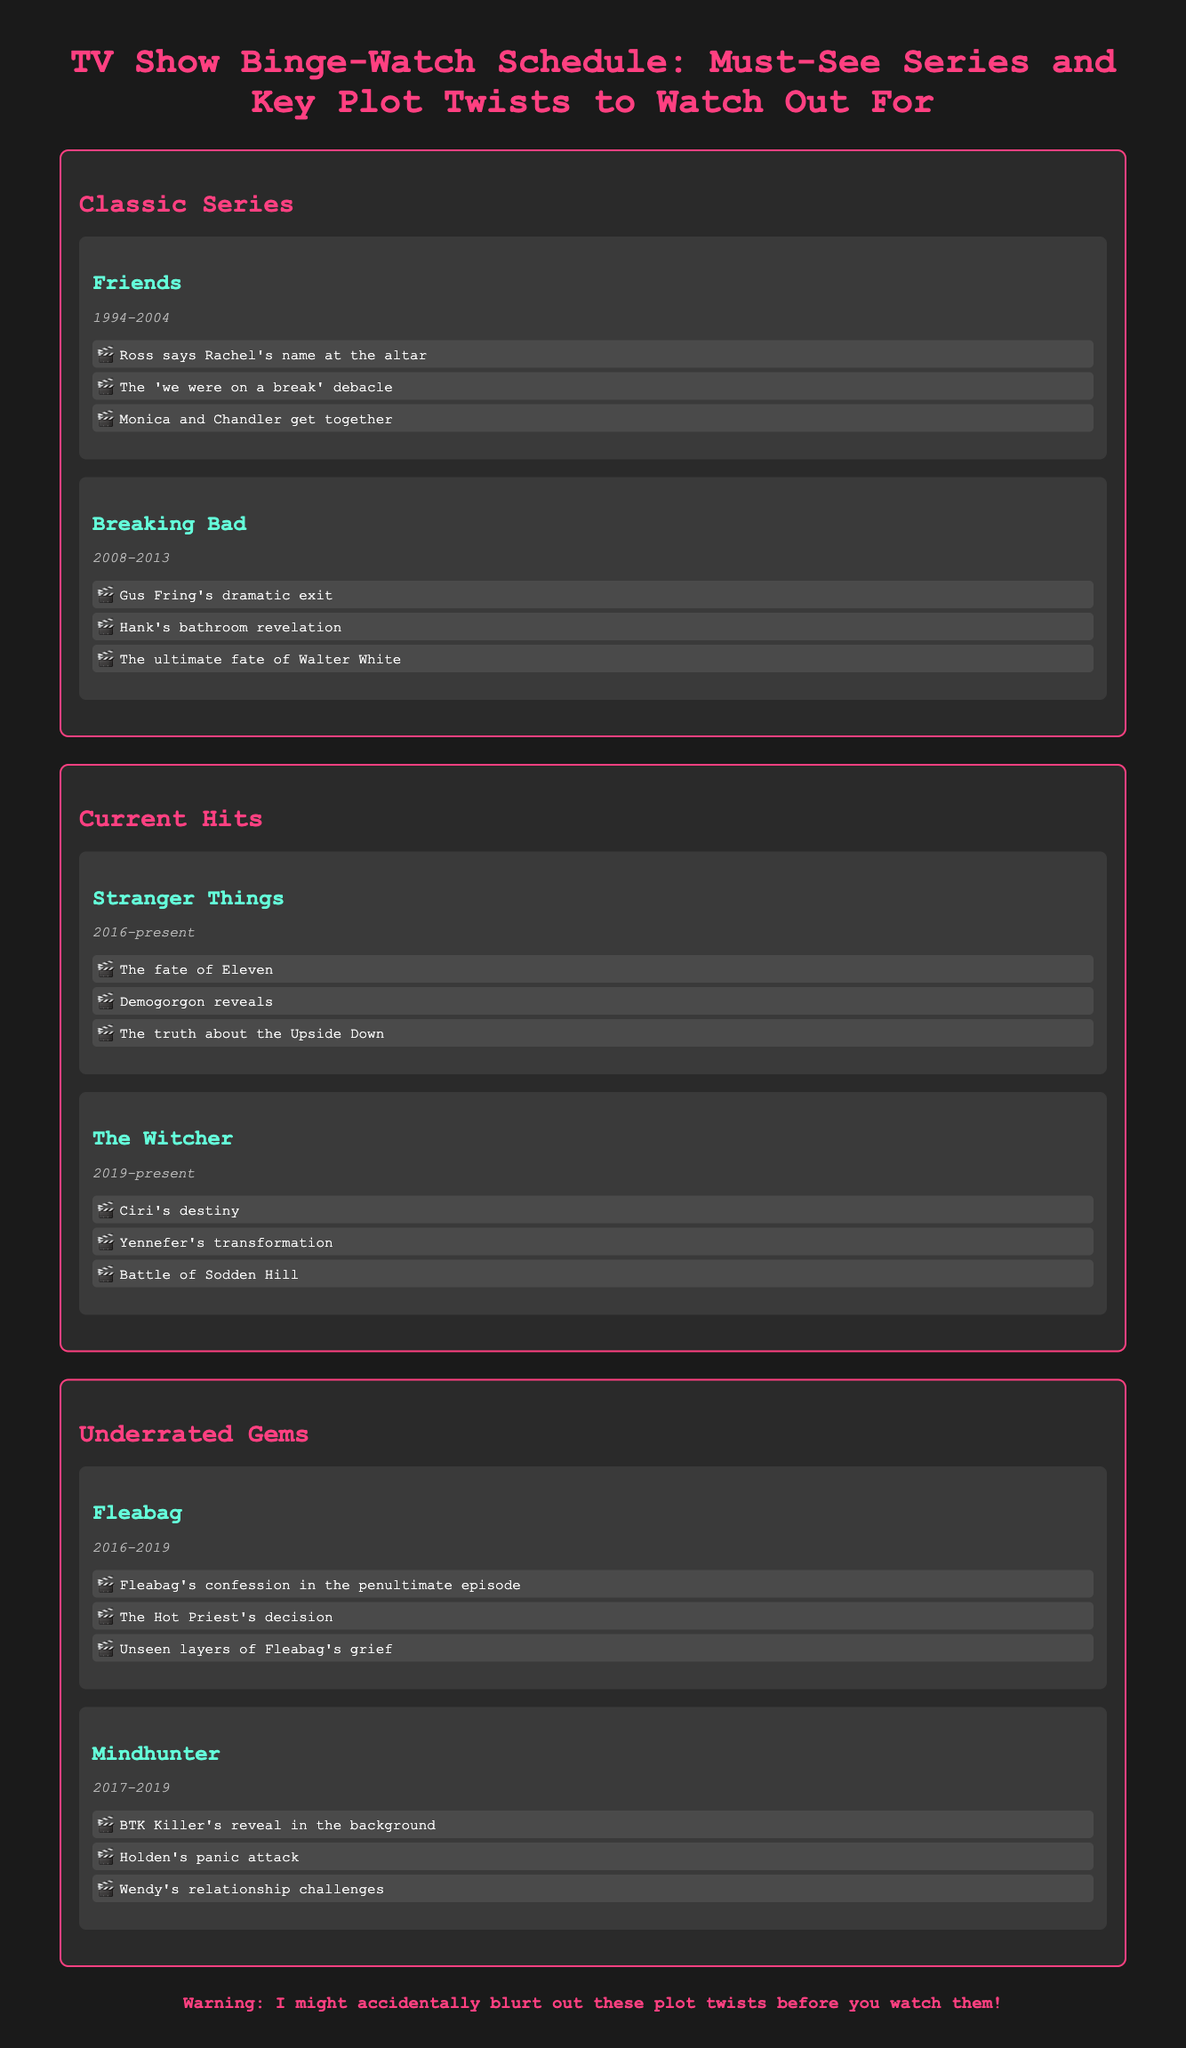What years did Friends air? Friends aired from 1994 to 2004, as stated in the document.
Answer: 1994-2004 What is a key plot twist from Breaking Bad? The document lists plot twists from Breaking Bad, including Gus Fring's dramatic exit.
Answer: Gus Fring's dramatic exit Which series is currently airing and premiered in 2019? The Witcher premiered in 2019 and is mentioned in the current hits section of the document.
Answer: The Witcher What significant event occurs in Fleabag? The document highlights several plot twists in Fleabag, one being Fleabag's confession in the penultimate episode.
Answer: Fleabag's confession in the penultimate episode How many plot twists are listed for Stranger Things? The document lists three plot twists under Stranger Things.
Answer: Three What genre do Friends and Breaking Bad belong to? Both series are identified as classic series in the infographic.
Answer: Classic Series What color is used for section titles? The section titles are colored in pink as indicated in the styling of the document.
Answer: Pink Which show mentions a character named Ciri? The Witcher is the show that features Ciri in the context of a key plot twist.
Answer: The Witcher What is the purpose of the warning at the bottom of the document? The warning alerts viewers that plot twists may be unintentionally revealed.
Answer: To warn about accidental spoilers 